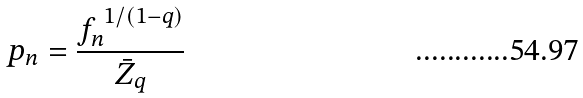<formula> <loc_0><loc_0><loc_500><loc_500>p _ { n } = \frac { f _ { n } ^ { \ 1 / ( 1 - q ) } } { \bar { Z } _ { q } }</formula> 